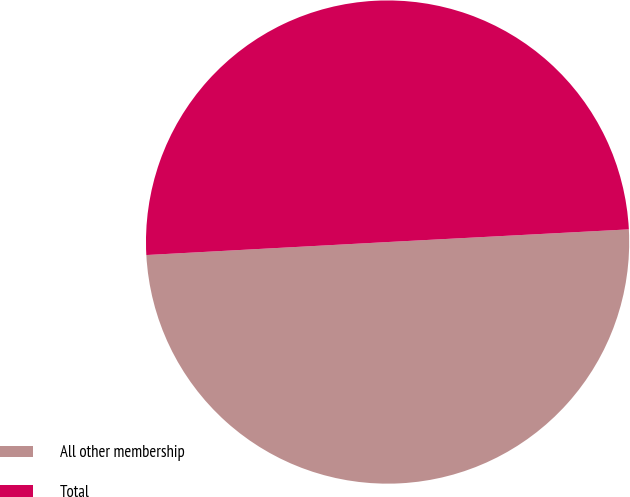<chart> <loc_0><loc_0><loc_500><loc_500><pie_chart><fcel>All other membership<fcel>Total<nl><fcel>49.98%<fcel>50.02%<nl></chart> 